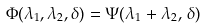Convert formula to latex. <formula><loc_0><loc_0><loc_500><loc_500>\Phi ( \lambda _ { 1 } , \lambda _ { 2 } , \delta ) = \Psi ( \lambda _ { 1 } + \lambda _ { 2 } , \, \delta )</formula> 